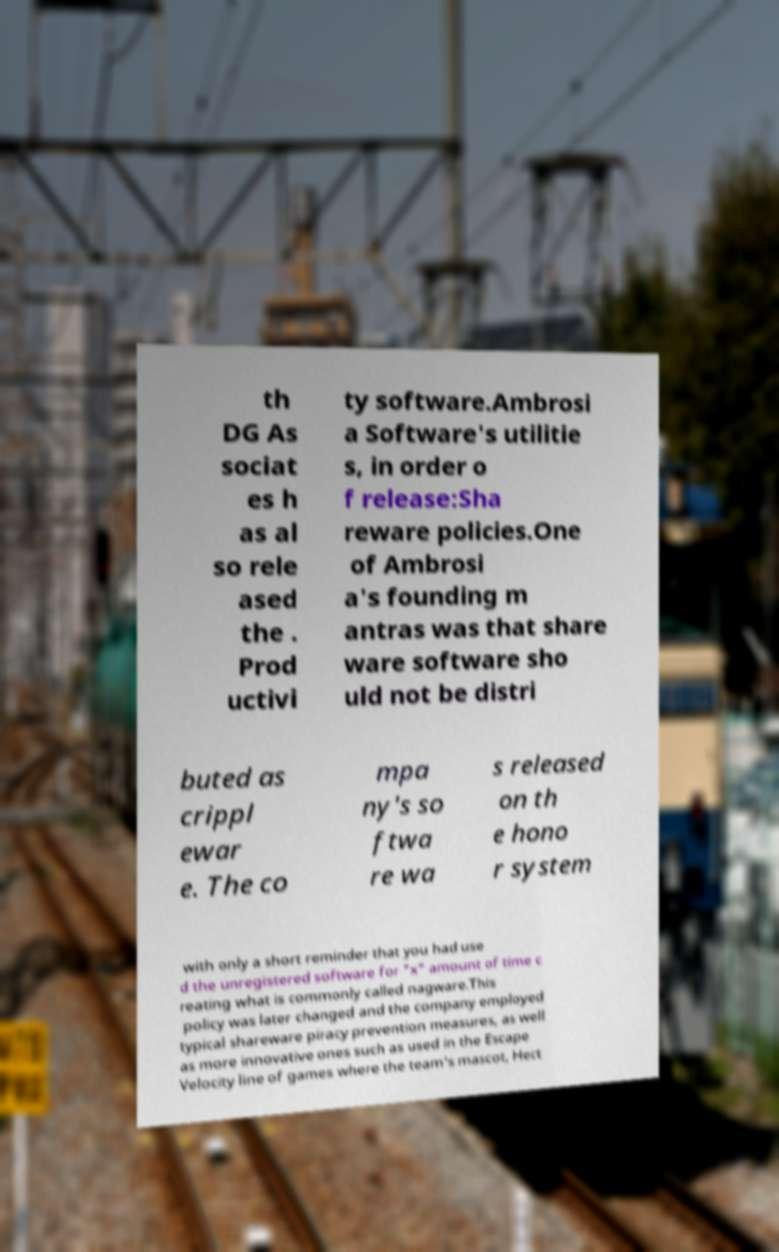Please read and relay the text visible in this image. What does it say? th DG As sociat es h as al so rele ased the . Prod uctivi ty software.Ambrosi a Software's utilitie s, in order o f release:Sha reware policies.One of Ambrosi a's founding m antras was that share ware software sho uld not be distri buted as crippl ewar e. The co mpa ny's so ftwa re wa s released on th e hono r system with only a short reminder that you had use d the unregistered software for "x" amount of time c reating what is commonly called nagware.This policy was later changed and the company employed typical shareware piracy prevention measures, as well as more innovative ones such as used in the Escape Velocity line of games where the team's mascot, Hect 